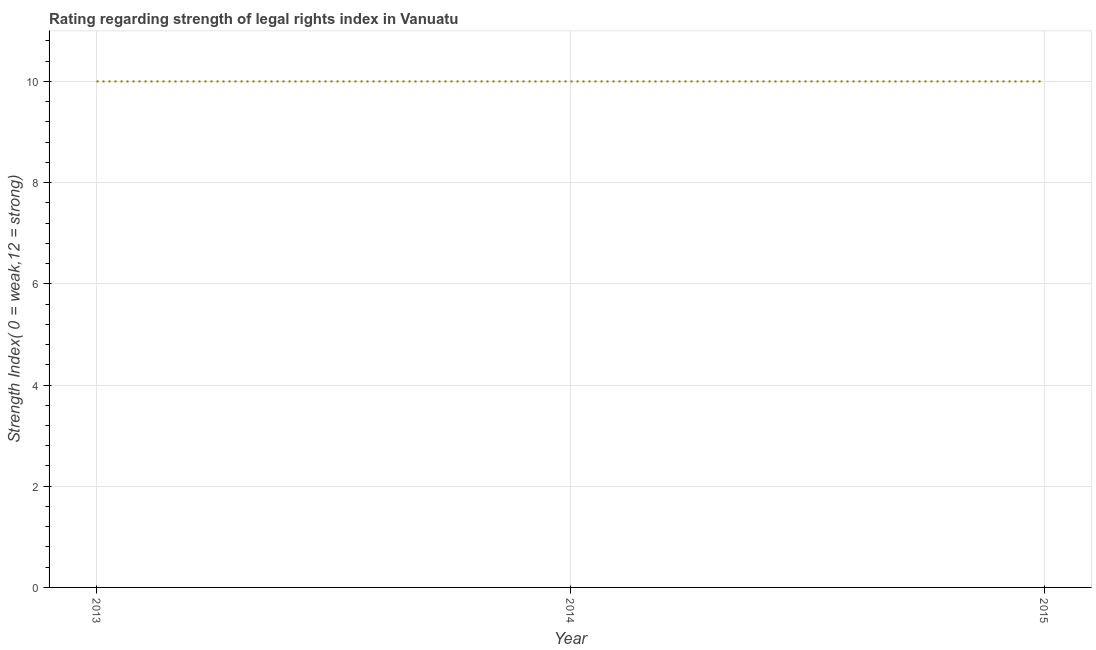What is the strength of legal rights index in 2015?
Provide a succinct answer. 10. Across all years, what is the maximum strength of legal rights index?
Keep it short and to the point. 10. Across all years, what is the minimum strength of legal rights index?
Provide a short and direct response. 10. In which year was the strength of legal rights index maximum?
Offer a very short reply. 2013. In which year was the strength of legal rights index minimum?
Make the answer very short. 2013. What is the sum of the strength of legal rights index?
Your response must be concise. 30. What is the difference between the strength of legal rights index in 2013 and 2014?
Provide a succinct answer. 0. In how many years, is the strength of legal rights index greater than 4.4 ?
Your answer should be very brief. 3. What is the ratio of the strength of legal rights index in 2014 to that in 2015?
Keep it short and to the point. 1. Is the strength of legal rights index in 2013 less than that in 2015?
Your answer should be compact. No. What is the difference between the highest and the second highest strength of legal rights index?
Provide a short and direct response. 0. Is the sum of the strength of legal rights index in 2013 and 2014 greater than the maximum strength of legal rights index across all years?
Offer a very short reply. Yes. In how many years, is the strength of legal rights index greater than the average strength of legal rights index taken over all years?
Your answer should be compact. 0. Does the strength of legal rights index monotonically increase over the years?
Offer a terse response. No. How many years are there in the graph?
Give a very brief answer. 3. What is the difference between two consecutive major ticks on the Y-axis?
Offer a terse response. 2. What is the title of the graph?
Your answer should be very brief. Rating regarding strength of legal rights index in Vanuatu. What is the label or title of the Y-axis?
Provide a succinct answer. Strength Index( 0 = weak,12 = strong). What is the Strength Index( 0 = weak,12 = strong) of 2014?
Offer a terse response. 10. What is the difference between the Strength Index( 0 = weak,12 = strong) in 2013 and 2014?
Provide a short and direct response. 0. What is the ratio of the Strength Index( 0 = weak,12 = strong) in 2013 to that in 2015?
Offer a very short reply. 1. 